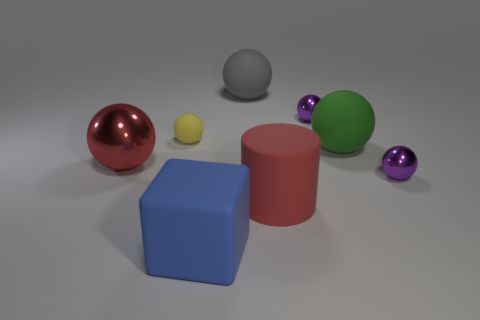Are there any other things that are made of the same material as the big blue thing?
Make the answer very short. Yes. What size is the gray rubber thing that is the same shape as the green object?
Your answer should be very brief. Large. What material is the tiny thing that is right of the yellow ball and behind the green object?
Offer a terse response. Metal. Is the color of the big rubber cube that is in front of the small yellow matte ball the same as the tiny matte thing?
Keep it short and to the point. No. There is a block; is its color the same as the small object on the left side of the gray rubber object?
Your answer should be very brief. No. There is a big blue cube; are there any big blocks on the left side of it?
Ensure brevity in your answer.  No. Is the big blue cube made of the same material as the large green sphere?
Keep it short and to the point. Yes. There is a gray ball that is the same size as the block; what is its material?
Offer a terse response. Rubber. What number of things are big gray rubber spheres that are to the right of the blue rubber thing or big gray rubber balls?
Provide a succinct answer. 1. Are there an equal number of red spheres that are to the left of the large red shiny thing and big cyan metal spheres?
Ensure brevity in your answer.  Yes. 